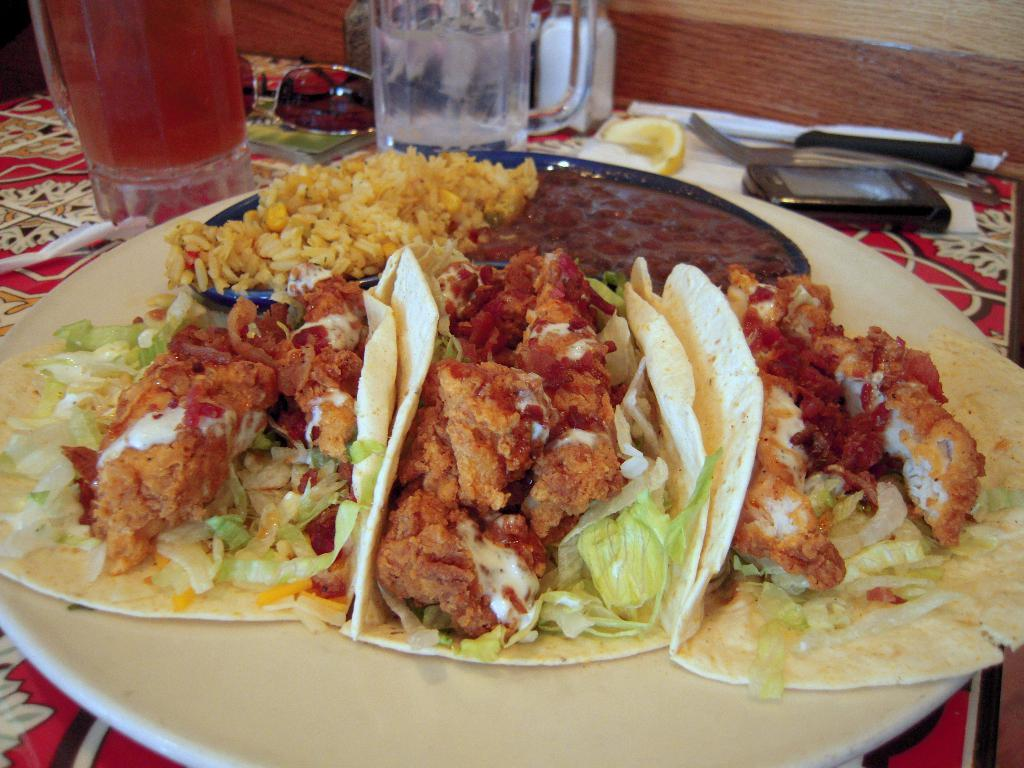What is on the plate in the image? There are food items served on a plate in the image. What can be seen beside the plate? There are glasses beside the plate. What other item is present beside the plate? Goggles are present beside the plate. What electronic device is visible in the image? A mobile phone is visible in the image. What is the common location for all the items mentioned? All the items mentioned are kept on a table. What type of punishment is being served on the plate in the image? There is no punishment being served on the plate in the image; it contains food items. 